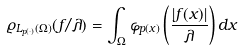<formula> <loc_0><loc_0><loc_500><loc_500>\varrho _ { L _ { p ( \cdot ) } ( \Omega ) } ( f / \lambda ) = \int _ { \Omega } \varphi _ { p ( x ) } \left ( \frac { | f ( x ) | } { \lambda } \right ) d x</formula> 